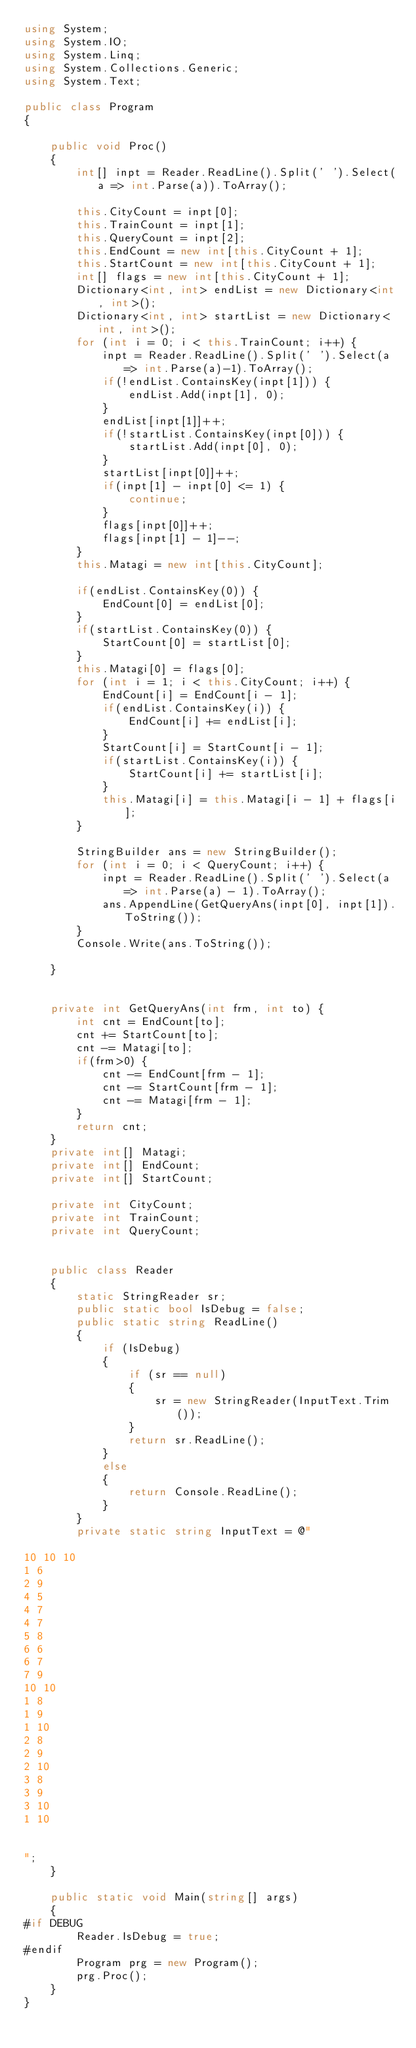<code> <loc_0><loc_0><loc_500><loc_500><_C#_>using System;
using System.IO;
using System.Linq;
using System.Collections.Generic;
using System.Text;

public class Program
{

    public void Proc()
    {
        int[] inpt = Reader.ReadLine().Split(' ').Select(a => int.Parse(a)).ToArray();

        this.CityCount = inpt[0];
        this.TrainCount = inpt[1];
        this.QueryCount = inpt[2];
        this.EndCount = new int[this.CityCount + 1];
        this.StartCount = new int[this.CityCount + 1];
        int[] flags = new int[this.CityCount + 1];
        Dictionary<int, int> endList = new Dictionary<int, int>();
        Dictionary<int, int> startList = new Dictionary<int, int>();
        for (int i = 0; i < this.TrainCount; i++) {
            inpt = Reader.ReadLine().Split(' ').Select(a => int.Parse(a)-1).ToArray();
            if(!endList.ContainsKey(inpt[1])) {
                endList.Add(inpt[1], 0);
            }
            endList[inpt[1]]++;
            if(!startList.ContainsKey(inpt[0])) {
                startList.Add(inpt[0], 0);
            }
            startList[inpt[0]]++;
            if(inpt[1] - inpt[0] <= 1) {
                continue;
            }
            flags[inpt[0]]++;
            flags[inpt[1] - 1]--;
        }
        this.Matagi = new int[this.CityCount];

        if(endList.ContainsKey(0)) {
            EndCount[0] = endList[0];
        }
        if(startList.ContainsKey(0)) {
            StartCount[0] = startList[0];
        }
        this.Matagi[0] = flags[0];
        for (int i = 1; i < this.CityCount; i++) {
            EndCount[i] = EndCount[i - 1];
            if(endList.ContainsKey(i)) {
                EndCount[i] += endList[i];
            }
            StartCount[i] = StartCount[i - 1];
            if(startList.ContainsKey(i)) {
                StartCount[i] += startList[i];
            }
            this.Matagi[i] = this.Matagi[i - 1] + flags[i];
        }

        StringBuilder ans = new StringBuilder();
        for (int i = 0; i < QueryCount; i++) {
            inpt = Reader.ReadLine().Split(' ').Select(a => int.Parse(a) - 1).ToArray();
            ans.AppendLine(GetQueryAns(inpt[0], inpt[1]).ToString());
        }
        Console.Write(ans.ToString());

    }


    private int GetQueryAns(int frm, int to) {
        int cnt = EndCount[to];
        cnt += StartCount[to];
        cnt -= Matagi[to];
        if(frm>0) {
            cnt -= EndCount[frm - 1];
            cnt -= StartCount[frm - 1];
            cnt -= Matagi[frm - 1];
        }
        return cnt;
    }
    private int[] Matagi;
    private int[] EndCount;
    private int[] StartCount;

    private int CityCount;
    private int TrainCount;
    private int QueryCount;


    public class Reader
    {
        static StringReader sr;
        public static bool IsDebug = false;
        public static string ReadLine()
        {
            if (IsDebug)
            {
                if (sr == null)
                {
                    sr = new StringReader(InputText.Trim());
                }
                return sr.ReadLine();
            }
            else
            {
                return Console.ReadLine();
            }
        }
        private static string InputText = @"

10 10 10
1 6
2 9
4 5
4 7
4 7
5 8
6 6
6 7
7 9
10 10
1 8
1 9
1 10
2 8
2 9
2 10
3 8
3 9
3 10
1 10


";
    }

    public static void Main(string[] args)
    {
#if DEBUG
        Reader.IsDebug = true;
#endif
        Program prg = new Program();
        prg.Proc();
    }
}
</code> 